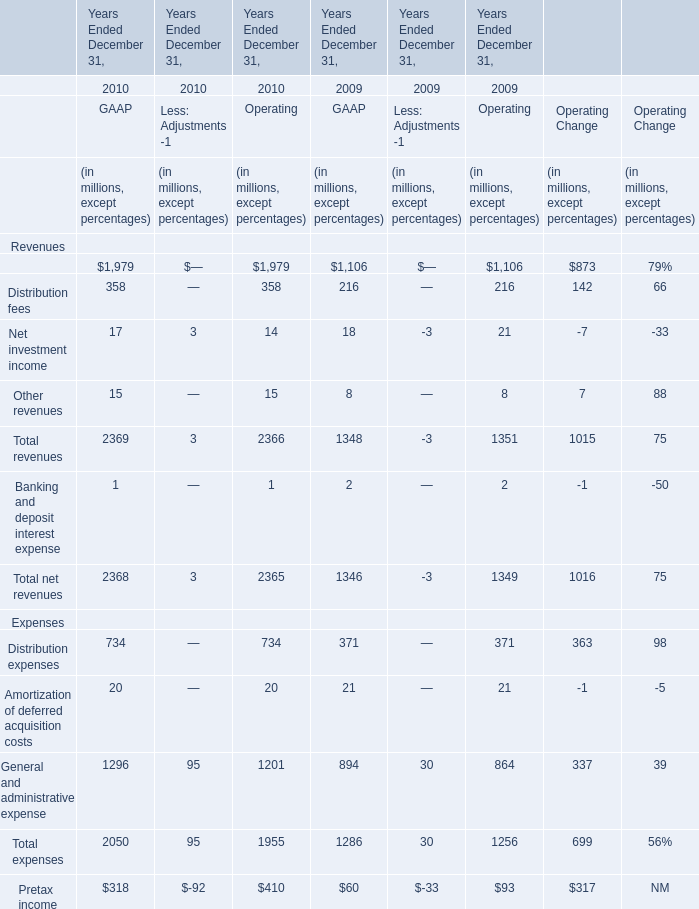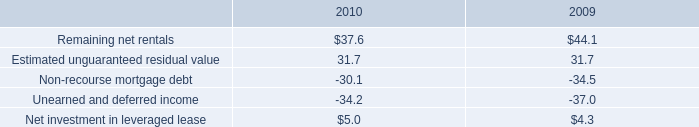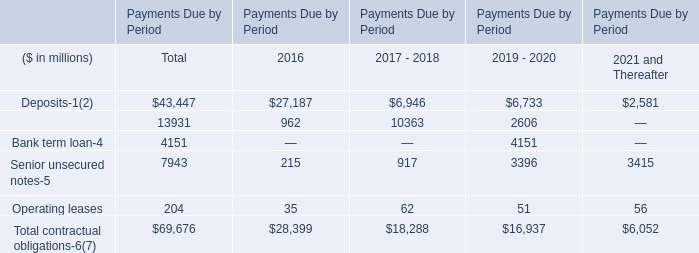as of dec 31 , 2010 , what was the average sale price , in millions , for the properties that were sold? 
Computations: (31.2 / 18)
Answer: 1.73333. 